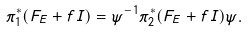Convert formula to latex. <formula><loc_0><loc_0><loc_500><loc_500>\pi _ { 1 } ^ { * } ( F _ { E } + f I ) = \psi ^ { - 1 } \pi _ { 2 } ^ { * } ( F _ { E } + f I ) \psi .</formula> 